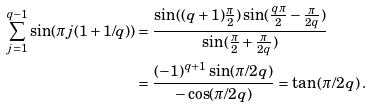<formula> <loc_0><loc_0><loc_500><loc_500>\sum _ { j = 1 } ^ { q - 1 } \sin ( \pi j ( 1 + 1 / q ) ) & = \frac { \sin ( ( q + 1 ) \frac { \pi } 2 ) \sin ( \frac { q \pi } 2 - \frac { \pi } { 2 q } ) } { \sin ( \frac { \pi } 2 + \frac { \pi } { 2 q } ) } \\ & = \frac { ( - 1 ) ^ { q + 1 } \sin ( { \pi } / { 2 q } ) } { - \cos ( { \pi } / { 2 q } ) } = \tan \left ( { \pi } / { 2 q } \right ) .</formula> 